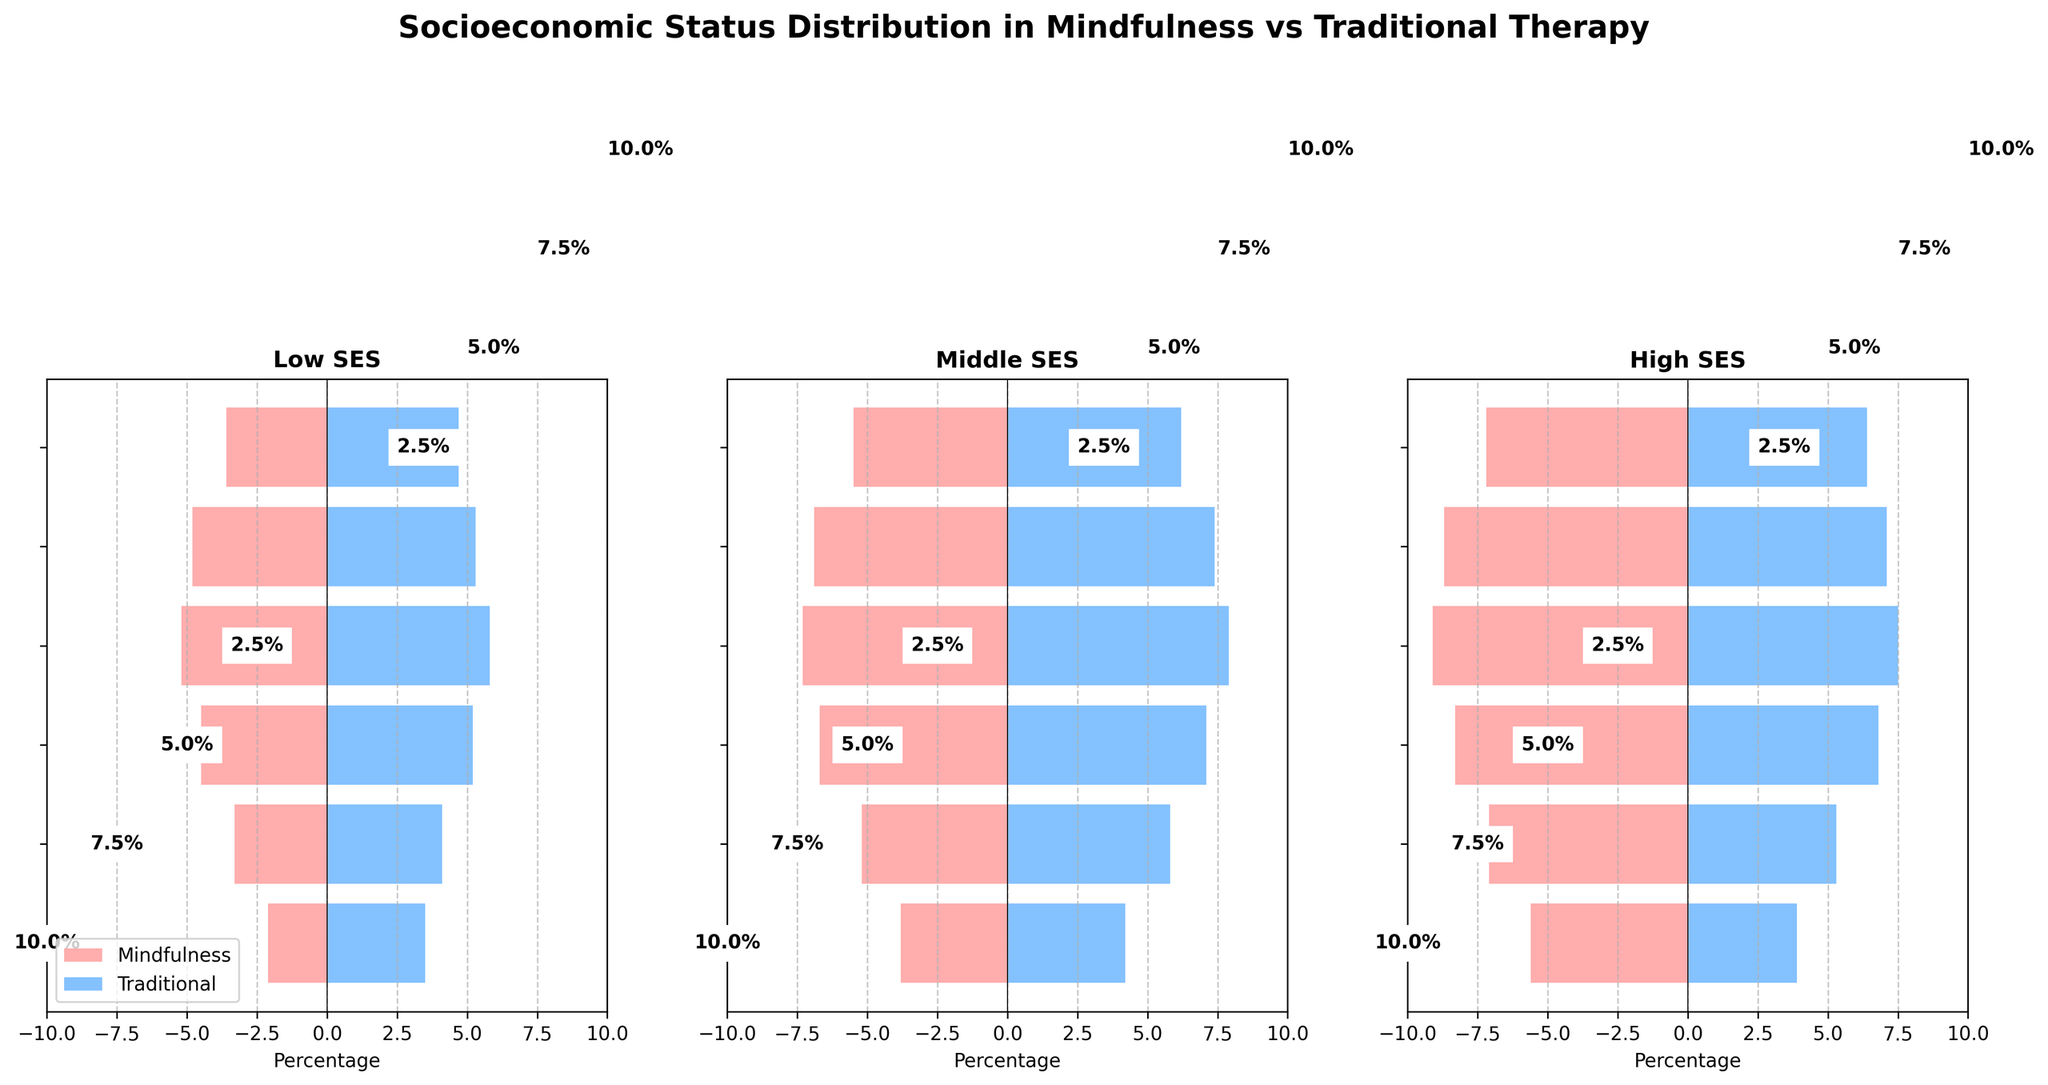What is the title of the figure? The title is prominently displayed at the top of the figure.
Answer: Socioeconomic Status Distribution in Mindfulness vs Traditional Therapy Which socio-economic status category has the highest percentage of individuals in mindfulness therapy aged 46-55? Look at the '46-55' age group within the three SES categories and compare percentages.
Answer: High SES For the 18-25 age group, which therapy type shows a higher percentage in the Low SES category? Compare the two bars for Low SES in the 18-25 age group.
Answer: Traditional How does the percentage of individuals in middle SES mindfulness therapy for the age group 26-35 compare to those in traditional therapy for the same SES and age group? Compare the lengths of the bars for middle SES in the 26-35 age group.
Answer: Mindfulness is 5.2%, Traditional is 5.8% What is the total percentage of individuals aged 56-65 seeking any type of therapy in the High SES category? Add the percentages for mindfulness and traditional therapies for the High SES category in the 56-65 age group (8.7% + 7.1%).
Answer: 15.8% Which age group demonstrates the largest difference in percentage between high SES individuals seeking traditional therapy versus mindfulness therapy? Calculate the difference for each age group and identify the largest one.
Answer: 46-55 (1.6% difference) Are there more individuals from the middle SES category seeking mindfulness-based therapy or traditional psychotherapy in the 36-45 age group? Compare the two percentages from the middle SES category in the 36-45 age group.
Answer: Traditional psychotherapy When comparing Low SES and High SES categories for those aged 66+, which category has a higher percentage in mindfulness therapy? Look at the percentages for Low SES and High SES in mindfulness therapy for the 66+ age group.
Answer: High SES In which SES category and age group combination is the difference in percentage between mindfulness and traditional therapy the smallest? Calculate the percentage differences for all SES category and age group combinations, identify the smallest.
Answer: Low SES, 56-65 (0.5% difference) What trend do you observe in the High SES category across different age groups for traditional therapy? Examine the percentages for High SES in traditional therapy across all age groups.
Answer: Percentages generally decrease with age, with the highest at 46-55 (7.5%) and the lowest at 18-25 (3.9%) 